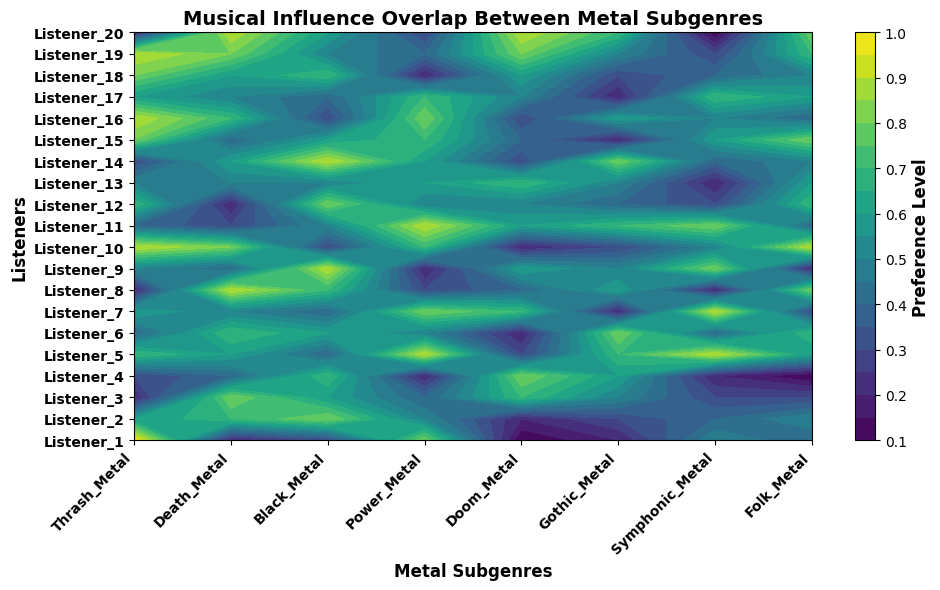What metal subgenre has the highest preference among listeners? To determine the subgenre with the highest preference, refer to the heatmap's color intensity for each subgenre. The brightest color indicates the highest preference value.
Answer: Thrash Metal Which listener shows the highest preference for Power Metal? Locate the Power Metal column and find the brightest (highest value) cell in that column. The corresponding row label identifies the listener.
Answer: Listener_5 How does the average preference for Black Metal compare to that for Symphonic Metal? Calculate the mean value for Black Metal preferences by averaging the values in the Black Metal column, then do the same for Symphonic Metal. Compare the two averages.
Answer: Black Metal average is higher Which subgenre is preferred the least by Listener_4? Examine the row corresponding to Listener_4 and find the cell with the darkest color (lowest preference value). The column label of this cell identifies the subgenre.
Answer: Folk Metal Between Death Metal and Gothic Metal, which subgenre shows a greater overall preference among all listeners? Compare the overall brightness of the Death Metal and Gothic Metal columns. The brighter column indicates a greater overall preference.
Answer: Death Metal What is the combined preference of Listener_10 for Thrash Metal and Symphonic Metal? Locate the cells for Thrash Metal and Symphonic Metal in Listener_10's row and sum their values (0.9 + 0.5).
Answer: 1.4 Is Power Metal more preferred than Doom Metal among the majority of listeners? Compare the overall color intensity of the Power Metal column with that of the Doom Metal column. The more consistently bright column indicates greater overall preference.
Answer: Yes Which two subgenres have the most similar preference patterns among listeners? Look for two columns with similar color gradients and distribution of intensity. Those with the most visually similar patterns indicate similar preference patterns.
Answer: Black Metal and Death Metal What is the median preference value for Folk Metal among all listeners? Sort the values in the Folk Metal column and find the middle value. If there's an even number of values, average the two middle numbers.
Answer: 0.5 How does Listener_15's preference for Thrash Metal compare to their preference for Doom Metal? Locate the cells for Thrash Metal and Doom Metal in Listener_15's row and compare the brightness (value) of the two cells.
Answer: Thrash Metal is higher 